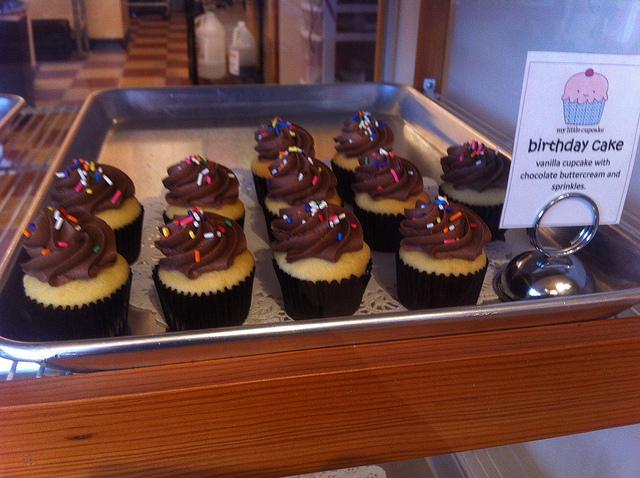How many cupcakes are on the table?
Answer briefly. 11. Are those cupcakes?
Short answer required. Yes. What type of icing is on the cupcakes?
Keep it brief. Chocolate. 